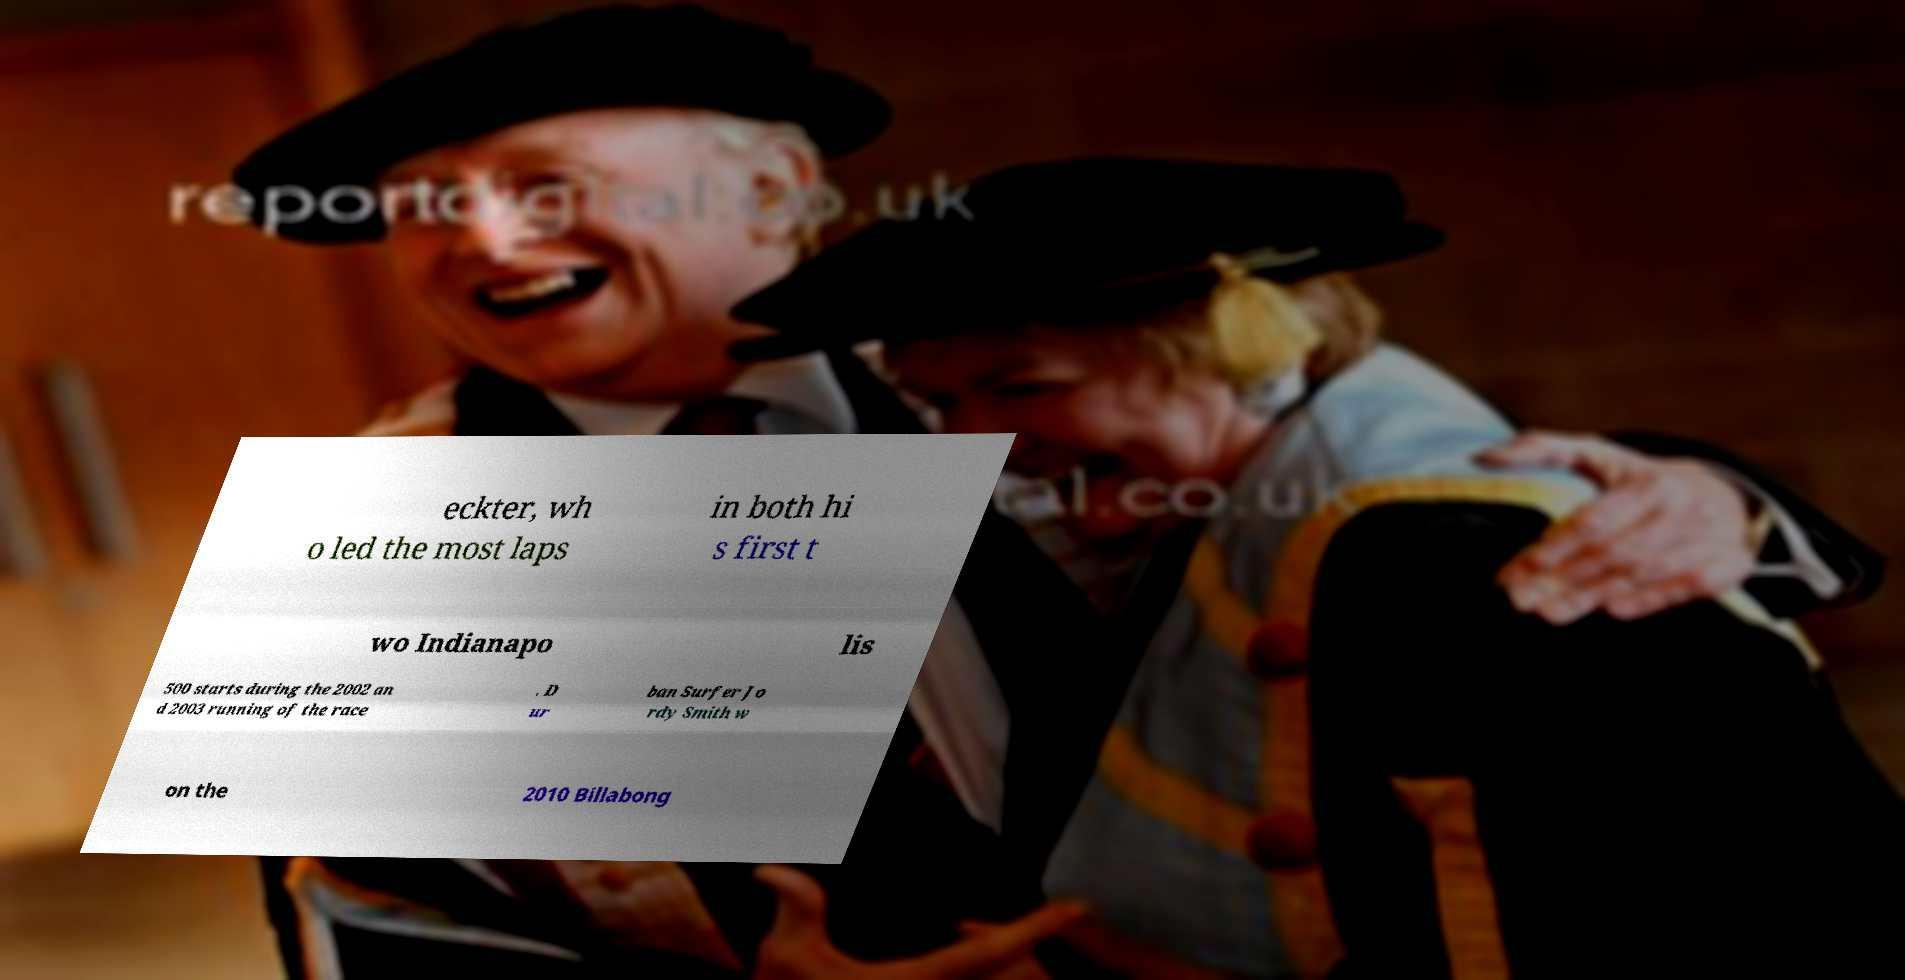Can you accurately transcribe the text from the provided image for me? eckter, wh o led the most laps in both hi s first t wo Indianapo lis 500 starts during the 2002 an d 2003 running of the race . D ur ban Surfer Jo rdy Smith w on the 2010 Billabong 